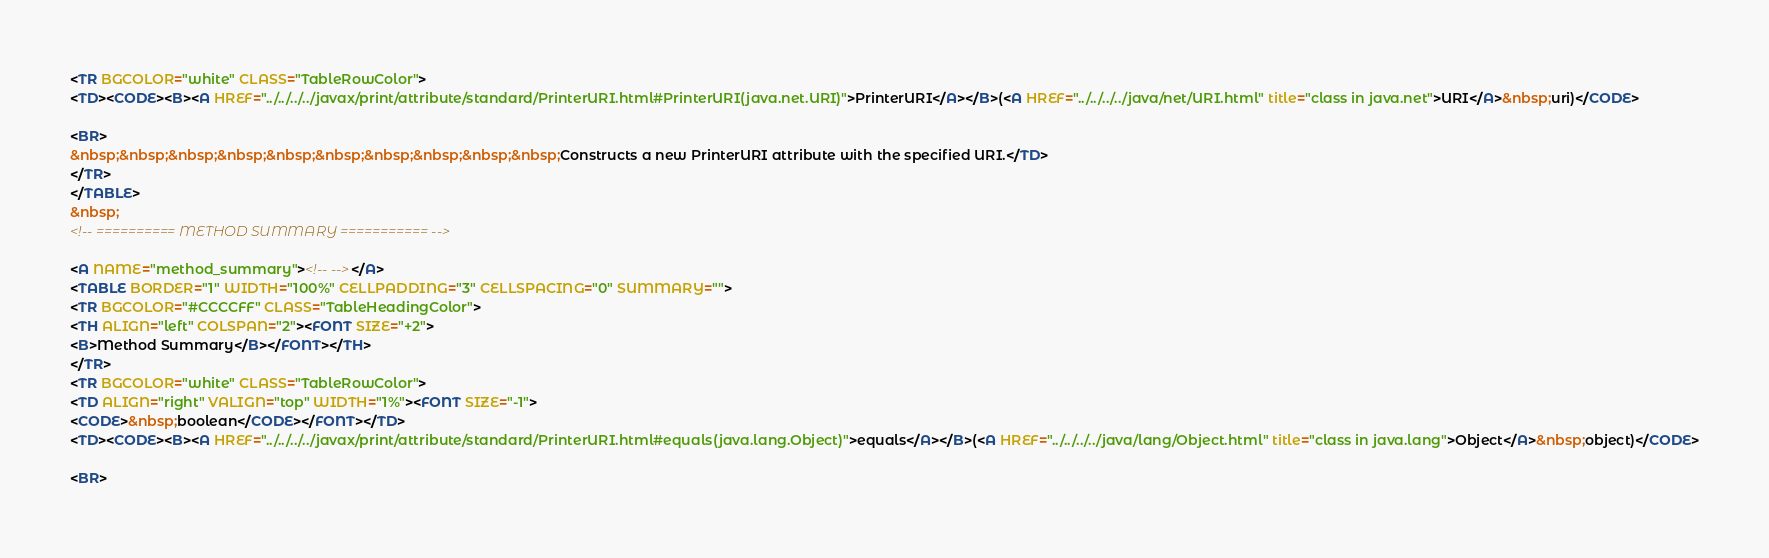Convert code to text. <code><loc_0><loc_0><loc_500><loc_500><_HTML_><TR BGCOLOR="white" CLASS="TableRowColor">
<TD><CODE><B><A HREF="../../../../javax/print/attribute/standard/PrinterURI.html#PrinterURI(java.net.URI)">PrinterURI</A></B>(<A HREF="../../../../java/net/URI.html" title="class in java.net">URI</A>&nbsp;uri)</CODE>

<BR>
&nbsp;&nbsp;&nbsp;&nbsp;&nbsp;&nbsp;&nbsp;&nbsp;&nbsp;&nbsp;Constructs a new PrinterURI attribute with the specified URI.</TD>
</TR>
</TABLE>
&nbsp;
<!-- ========== METHOD SUMMARY =========== -->

<A NAME="method_summary"><!-- --></A>
<TABLE BORDER="1" WIDTH="100%" CELLPADDING="3" CELLSPACING="0" SUMMARY="">
<TR BGCOLOR="#CCCCFF" CLASS="TableHeadingColor">
<TH ALIGN="left" COLSPAN="2"><FONT SIZE="+2">
<B>Method Summary</B></FONT></TH>
</TR>
<TR BGCOLOR="white" CLASS="TableRowColor">
<TD ALIGN="right" VALIGN="top" WIDTH="1%"><FONT SIZE="-1">
<CODE>&nbsp;boolean</CODE></FONT></TD>
<TD><CODE><B><A HREF="../../../../javax/print/attribute/standard/PrinterURI.html#equals(java.lang.Object)">equals</A></B>(<A HREF="../../../../java/lang/Object.html" title="class in java.lang">Object</A>&nbsp;object)</CODE>

<BR></code> 